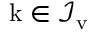Convert formula to latex. <formula><loc_0><loc_0><loc_500><loc_500>k \in \mathcal { I } _ { \mathrm v }</formula> 